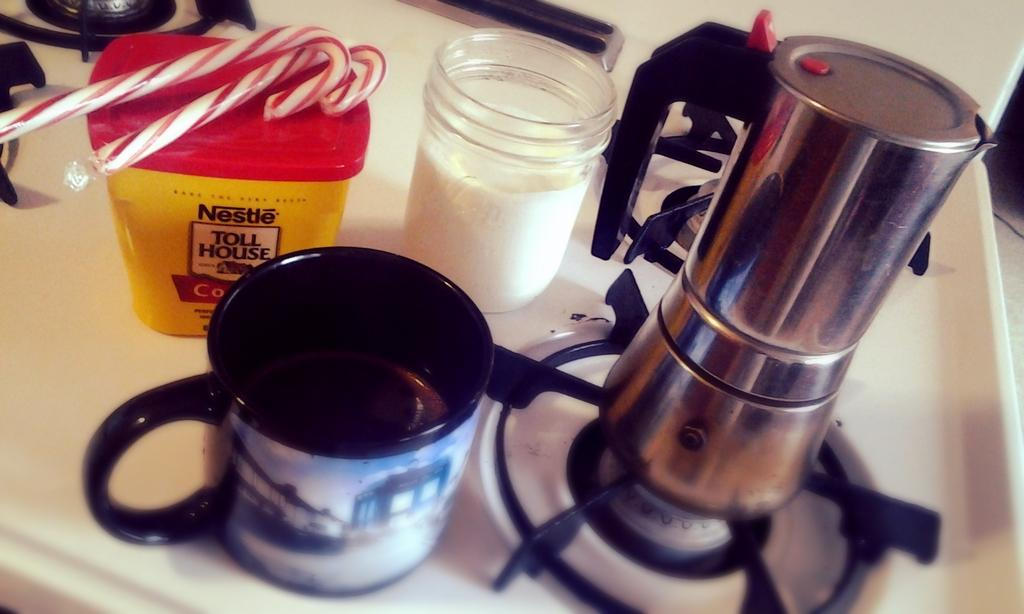What type of appliances can be seen in the image? There are stoves in the image. What level of experience does the beginner have with popcorn in the image? There is no information about popcorn or a beginner's experience in the image, as it only features stoves. 